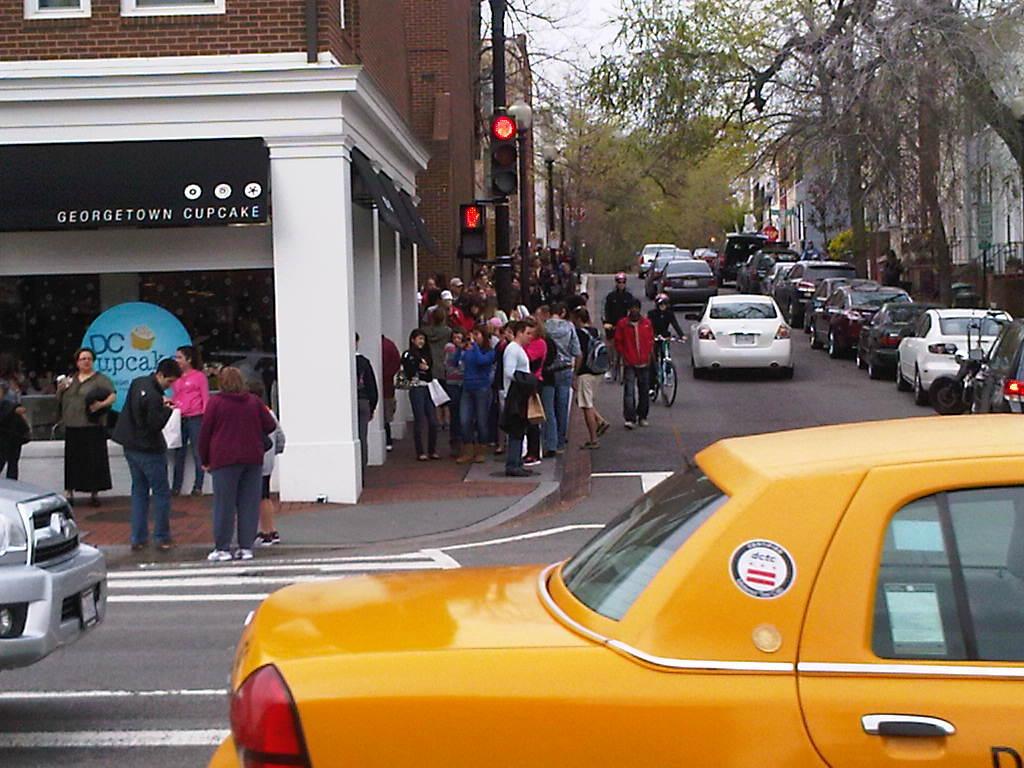What is the name of the cupcake shop?
Provide a short and direct response. Georgetown cupcake. 